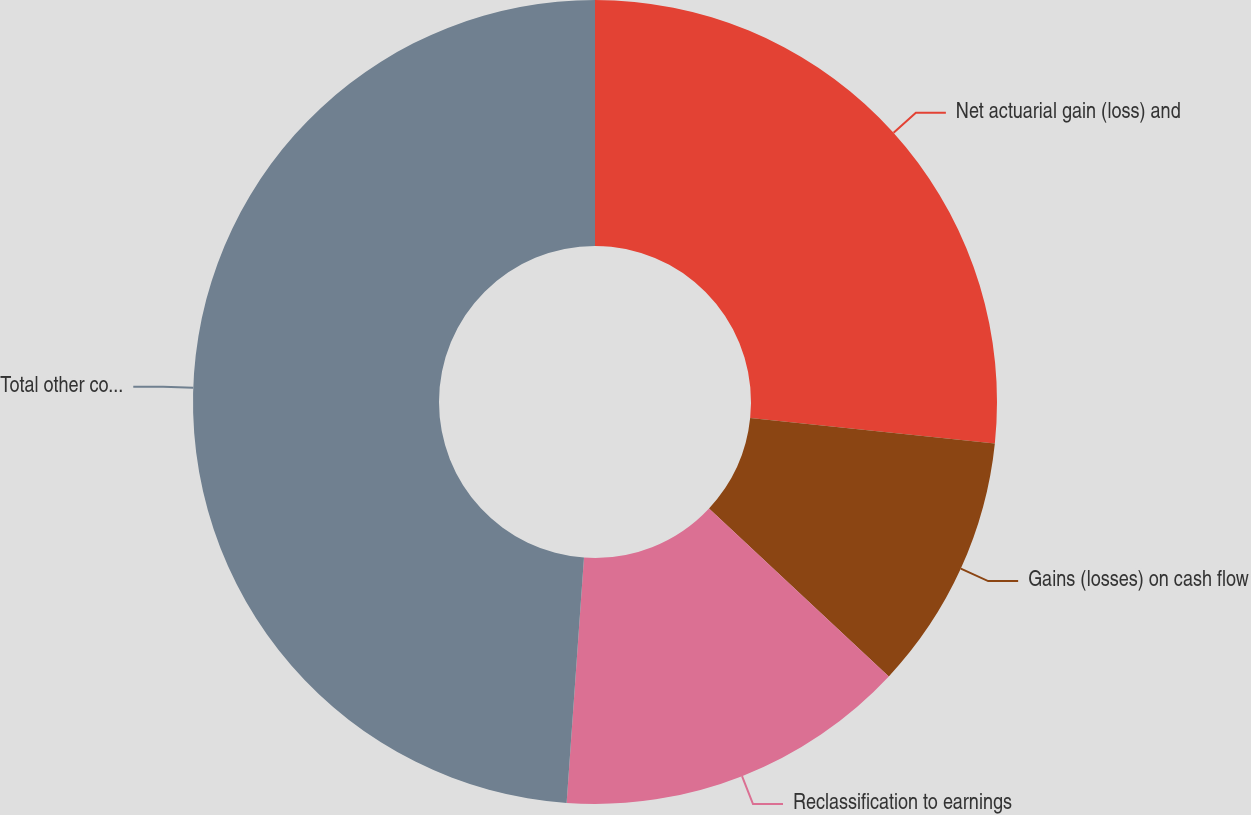Convert chart. <chart><loc_0><loc_0><loc_500><loc_500><pie_chart><fcel>Net actuarial gain (loss) and<fcel>Gains (losses) on cash flow<fcel>Reclassification to earnings<fcel>Total other comprehensive<nl><fcel>26.65%<fcel>10.31%<fcel>14.17%<fcel>48.88%<nl></chart> 